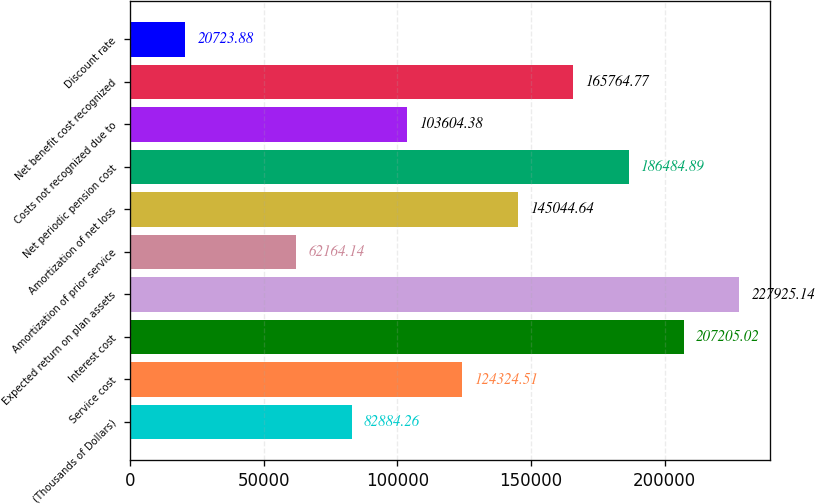Convert chart. <chart><loc_0><loc_0><loc_500><loc_500><bar_chart><fcel>(Thousands of Dollars)<fcel>Service cost<fcel>Interest cost<fcel>Expected return on plan assets<fcel>Amortization of prior service<fcel>Amortization of net loss<fcel>Net periodic pension cost<fcel>Costs not recognized due to<fcel>Net benefit cost recognized<fcel>Discount rate<nl><fcel>82884.3<fcel>124325<fcel>207205<fcel>227925<fcel>62164.1<fcel>145045<fcel>186485<fcel>103604<fcel>165765<fcel>20723.9<nl></chart> 